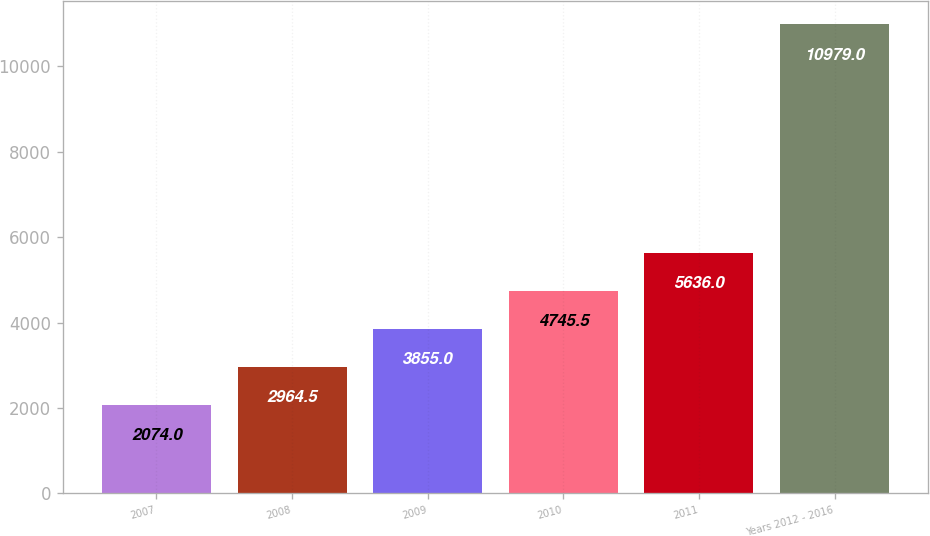Convert chart. <chart><loc_0><loc_0><loc_500><loc_500><bar_chart><fcel>2007<fcel>2008<fcel>2009<fcel>2010<fcel>2011<fcel>Years 2012 - 2016<nl><fcel>2074<fcel>2964.5<fcel>3855<fcel>4745.5<fcel>5636<fcel>10979<nl></chart> 